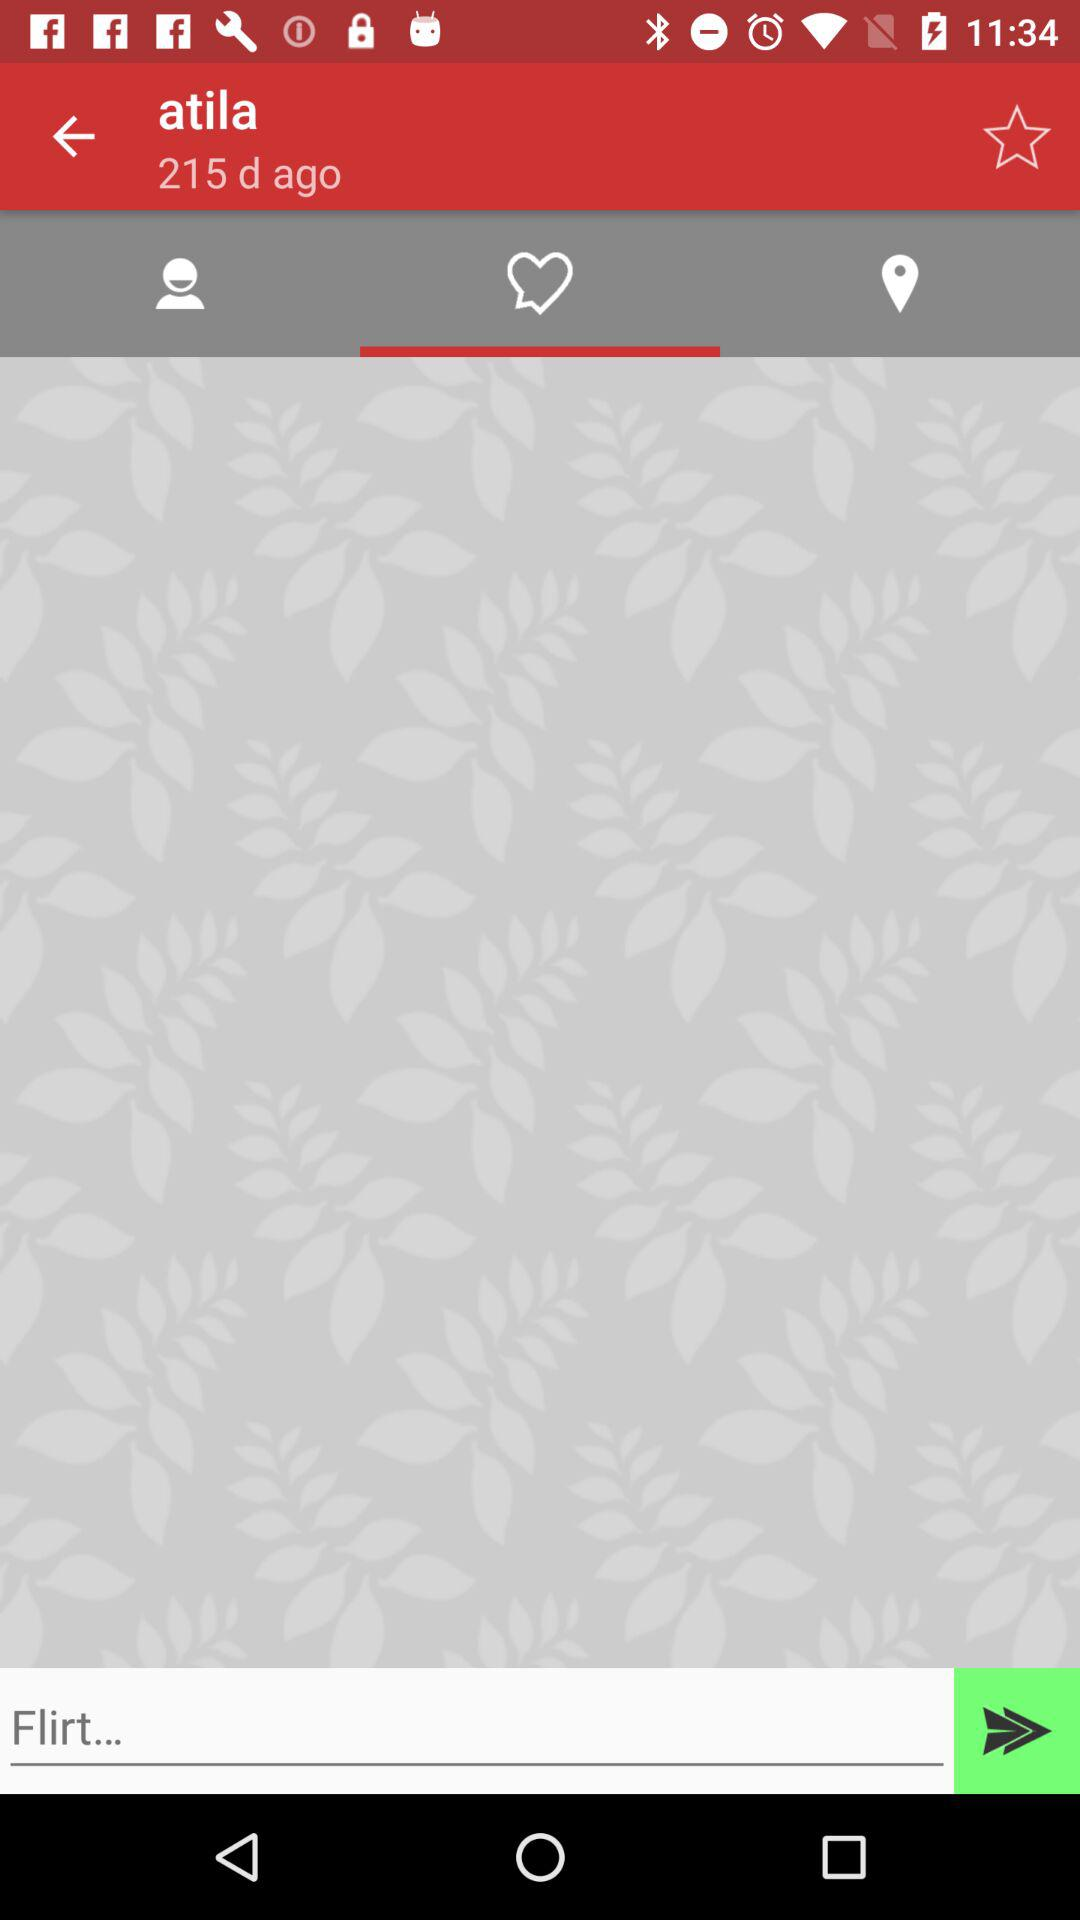What is the name of the user? The name of the user is Atila. 